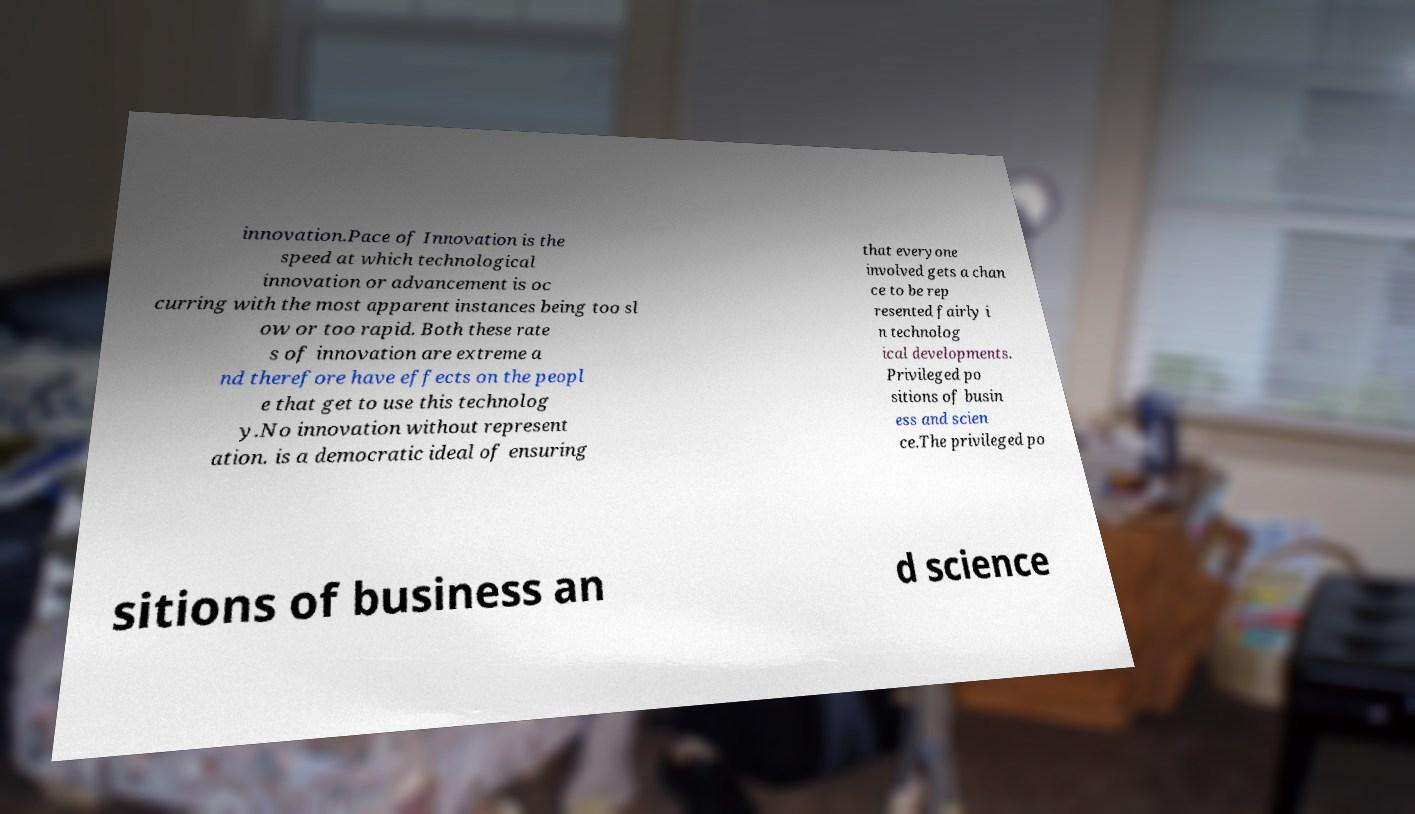There's text embedded in this image that I need extracted. Can you transcribe it verbatim? innovation.Pace of Innovation is the speed at which technological innovation or advancement is oc curring with the most apparent instances being too sl ow or too rapid. Both these rate s of innovation are extreme a nd therefore have effects on the peopl e that get to use this technolog y.No innovation without represent ation. is a democratic ideal of ensuring that everyone involved gets a chan ce to be rep resented fairly i n technolog ical developments. Privileged po sitions of busin ess and scien ce.The privileged po sitions of business an d science 